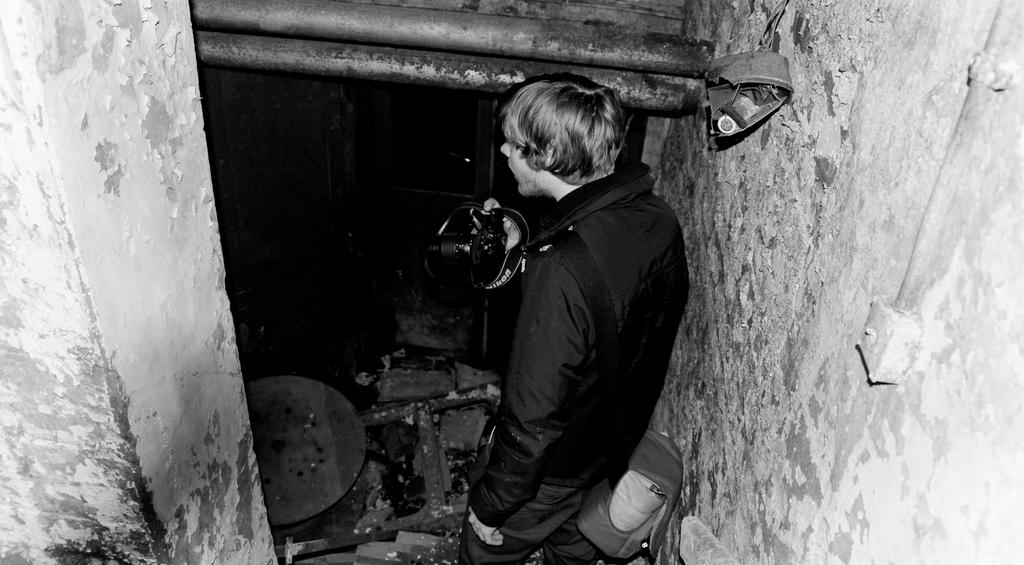What is the color scheme of the image? The image is black and white. Can you describe the person in the image? There is a person in the image, and they are holding a camera. What is the lighting condition in the room? The room in the image appears to be dark. How many children are playing with the sink in the image? There are no children or sink present in the image. What type of structure is visible in the background of the image? There is no structure visible in the background of the image; it is a dark room with a person holding a camera. 